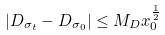<formula> <loc_0><loc_0><loc_500><loc_500>| D _ { \sigma _ { t } } - D _ { \sigma _ { 0 } } | \leq M _ { D } x _ { 0 } ^ { \frac { 1 } { 2 } }</formula> 